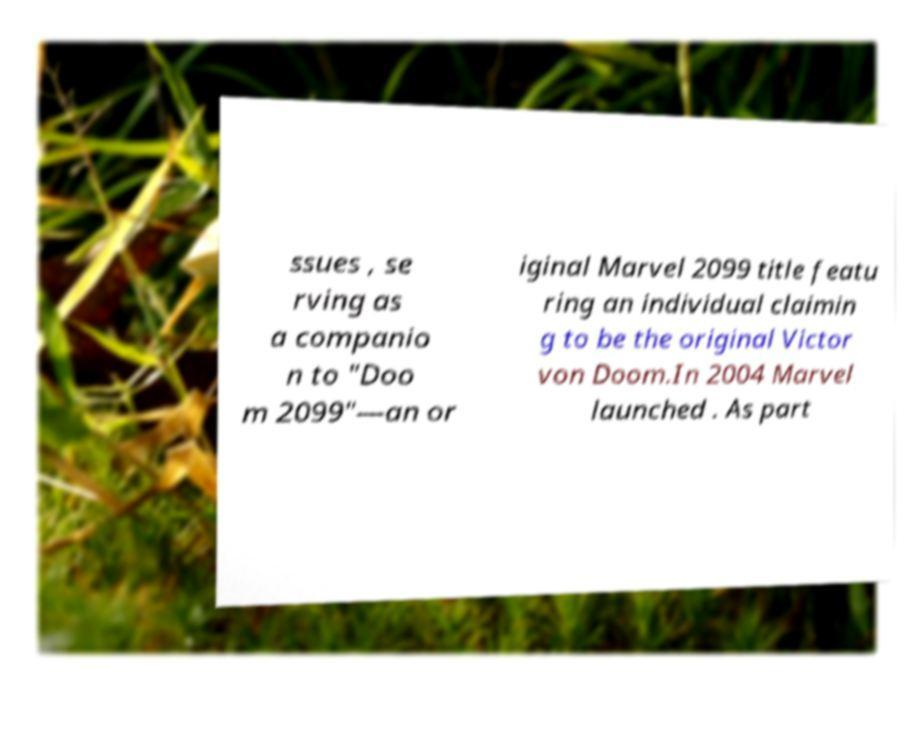There's text embedded in this image that I need extracted. Can you transcribe it verbatim? ssues , se rving as a companio n to "Doo m 2099"—an or iginal Marvel 2099 title featu ring an individual claimin g to be the original Victor von Doom.In 2004 Marvel launched . As part 